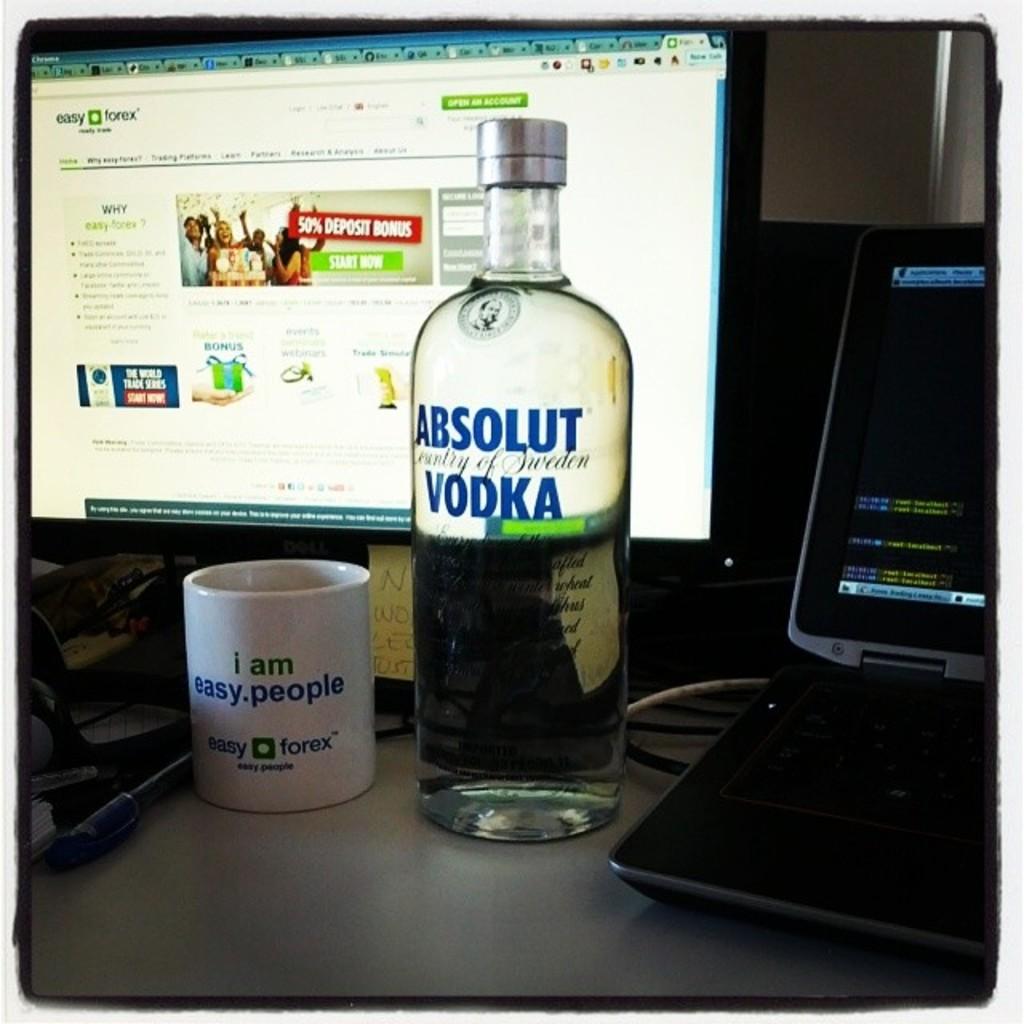What brand is this vodka?
Your answer should be compact. Absolut. What kind of people are you?
Give a very brief answer. Easy. 